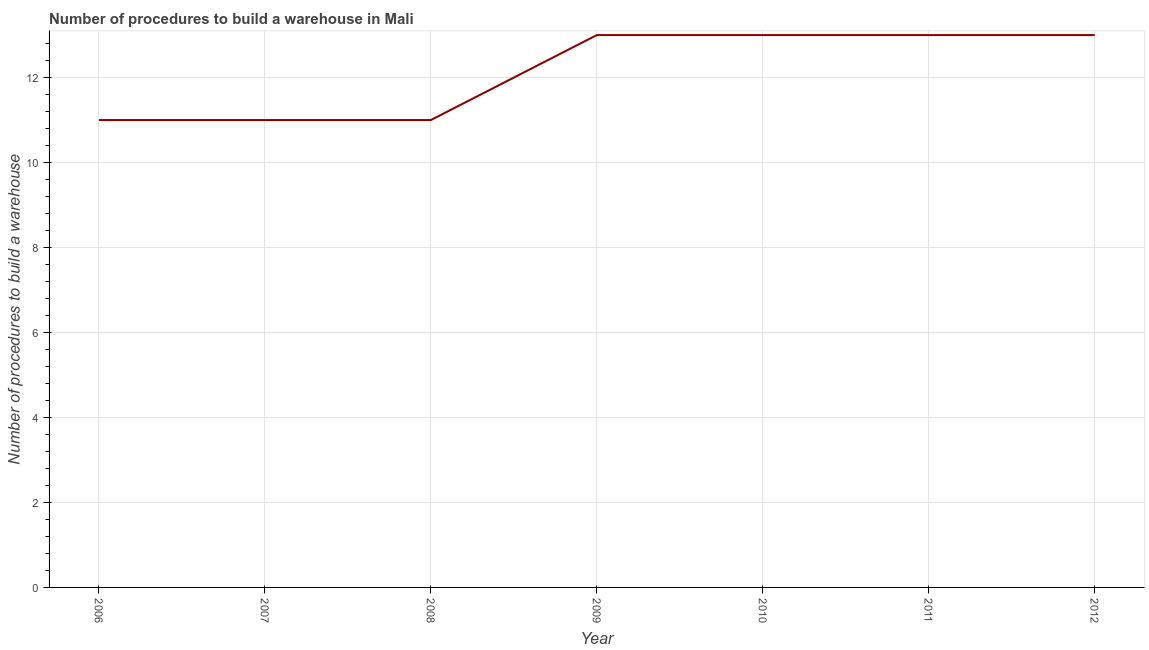What is the number of procedures to build a warehouse in 2011?
Give a very brief answer. 13. Across all years, what is the maximum number of procedures to build a warehouse?
Your answer should be very brief. 13. Across all years, what is the minimum number of procedures to build a warehouse?
Offer a terse response. 11. In which year was the number of procedures to build a warehouse minimum?
Keep it short and to the point. 2006. What is the sum of the number of procedures to build a warehouse?
Provide a succinct answer. 85. What is the average number of procedures to build a warehouse per year?
Make the answer very short. 12.14. What is the median number of procedures to build a warehouse?
Your answer should be very brief. 13. Do a majority of the years between 2009 and 2011 (inclusive) have number of procedures to build a warehouse greater than 5.6 ?
Your answer should be compact. Yes. What is the ratio of the number of procedures to build a warehouse in 2006 to that in 2009?
Your answer should be very brief. 0.85. Is the number of procedures to build a warehouse in 2008 less than that in 2011?
Offer a very short reply. Yes. Is the difference between the number of procedures to build a warehouse in 2006 and 2008 greater than the difference between any two years?
Your answer should be very brief. No. Is the sum of the number of procedures to build a warehouse in 2008 and 2009 greater than the maximum number of procedures to build a warehouse across all years?
Make the answer very short. Yes. What is the difference between the highest and the lowest number of procedures to build a warehouse?
Offer a terse response. 2. Are the values on the major ticks of Y-axis written in scientific E-notation?
Offer a terse response. No. Does the graph contain any zero values?
Your response must be concise. No. What is the title of the graph?
Your answer should be very brief. Number of procedures to build a warehouse in Mali. What is the label or title of the X-axis?
Give a very brief answer. Year. What is the label or title of the Y-axis?
Offer a very short reply. Number of procedures to build a warehouse. What is the Number of procedures to build a warehouse of 2007?
Keep it short and to the point. 11. What is the Number of procedures to build a warehouse in 2008?
Ensure brevity in your answer.  11. What is the Number of procedures to build a warehouse in 2009?
Provide a succinct answer. 13. What is the Number of procedures to build a warehouse of 2010?
Your response must be concise. 13. What is the Number of procedures to build a warehouse of 2012?
Your answer should be very brief. 13. What is the difference between the Number of procedures to build a warehouse in 2006 and 2007?
Ensure brevity in your answer.  0. What is the difference between the Number of procedures to build a warehouse in 2006 and 2011?
Give a very brief answer. -2. What is the difference between the Number of procedures to build a warehouse in 2006 and 2012?
Provide a short and direct response. -2. What is the difference between the Number of procedures to build a warehouse in 2007 and 2009?
Keep it short and to the point. -2. What is the difference between the Number of procedures to build a warehouse in 2007 and 2011?
Offer a terse response. -2. What is the difference between the Number of procedures to build a warehouse in 2007 and 2012?
Give a very brief answer. -2. What is the difference between the Number of procedures to build a warehouse in 2008 and 2009?
Offer a very short reply. -2. What is the difference between the Number of procedures to build a warehouse in 2008 and 2012?
Make the answer very short. -2. What is the difference between the Number of procedures to build a warehouse in 2009 and 2010?
Make the answer very short. 0. What is the difference between the Number of procedures to build a warehouse in 2009 and 2011?
Offer a very short reply. 0. What is the difference between the Number of procedures to build a warehouse in 2009 and 2012?
Your response must be concise. 0. What is the difference between the Number of procedures to build a warehouse in 2010 and 2011?
Make the answer very short. 0. What is the difference between the Number of procedures to build a warehouse in 2010 and 2012?
Your response must be concise. 0. What is the ratio of the Number of procedures to build a warehouse in 2006 to that in 2008?
Give a very brief answer. 1. What is the ratio of the Number of procedures to build a warehouse in 2006 to that in 2009?
Give a very brief answer. 0.85. What is the ratio of the Number of procedures to build a warehouse in 2006 to that in 2010?
Provide a succinct answer. 0.85. What is the ratio of the Number of procedures to build a warehouse in 2006 to that in 2011?
Make the answer very short. 0.85. What is the ratio of the Number of procedures to build a warehouse in 2006 to that in 2012?
Give a very brief answer. 0.85. What is the ratio of the Number of procedures to build a warehouse in 2007 to that in 2009?
Your answer should be compact. 0.85. What is the ratio of the Number of procedures to build a warehouse in 2007 to that in 2010?
Provide a succinct answer. 0.85. What is the ratio of the Number of procedures to build a warehouse in 2007 to that in 2011?
Your answer should be very brief. 0.85. What is the ratio of the Number of procedures to build a warehouse in 2007 to that in 2012?
Ensure brevity in your answer.  0.85. What is the ratio of the Number of procedures to build a warehouse in 2008 to that in 2009?
Give a very brief answer. 0.85. What is the ratio of the Number of procedures to build a warehouse in 2008 to that in 2010?
Provide a short and direct response. 0.85. What is the ratio of the Number of procedures to build a warehouse in 2008 to that in 2011?
Ensure brevity in your answer.  0.85. What is the ratio of the Number of procedures to build a warehouse in 2008 to that in 2012?
Provide a succinct answer. 0.85. 